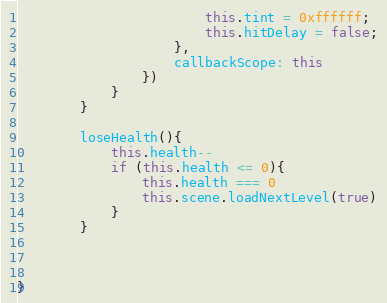<code> <loc_0><loc_0><loc_500><loc_500><_JavaScript_>                        this.tint = 0xffffff;
                        this.hitDelay = false;
                    },
                    callbackScope: this
                })
            }
        }

        loseHealth(){
            this.health--
            if (this.health <= 0){
                this.health === 0 
                this.scene.loadNextLevel(true)
            }
        }
    


}</code> 